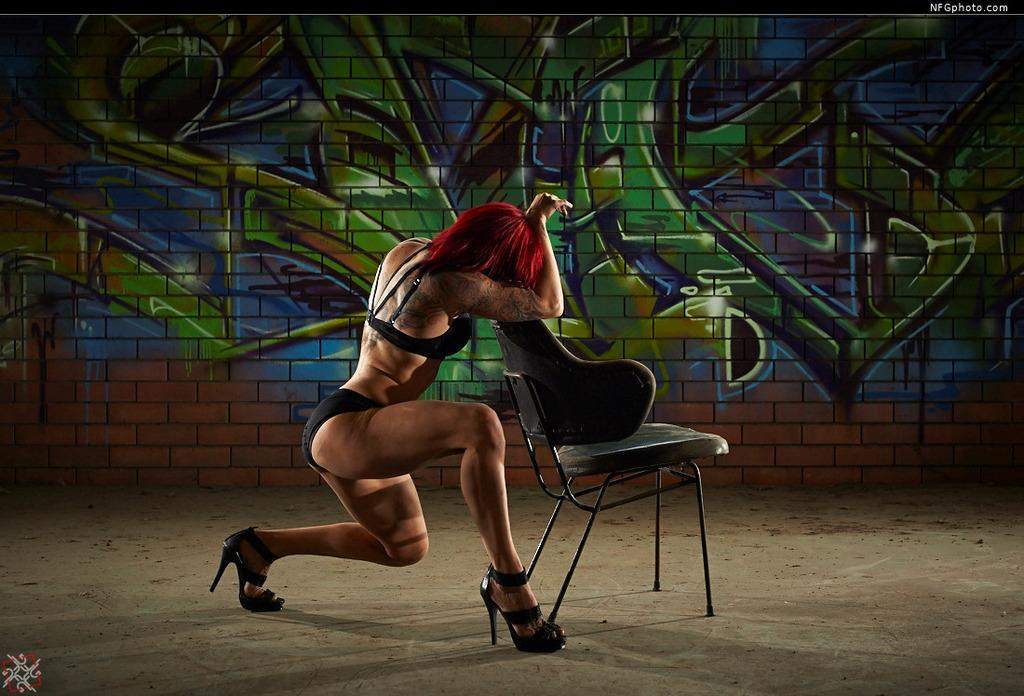Who is the main subject in the image? There is a lady in the image. What is in front of the lady? There is a chair in front of the lady. What can be seen in the background of the image? There is graffiti on the wall in the background of the image. Who is the creator of the weather in the image? There is no mention of weather in the image, so it is not possible to determine who the creator of the weather might be. 